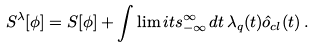<formula> <loc_0><loc_0><loc_500><loc_500>S ^ { \lambda } [ \phi ] = S [ \phi ] + \int \lim i t s _ { - \infty } ^ { \infty } \, d t \, \lambda _ { q } ( t ) \hat { o } _ { c l } ( t ) \, .</formula> 